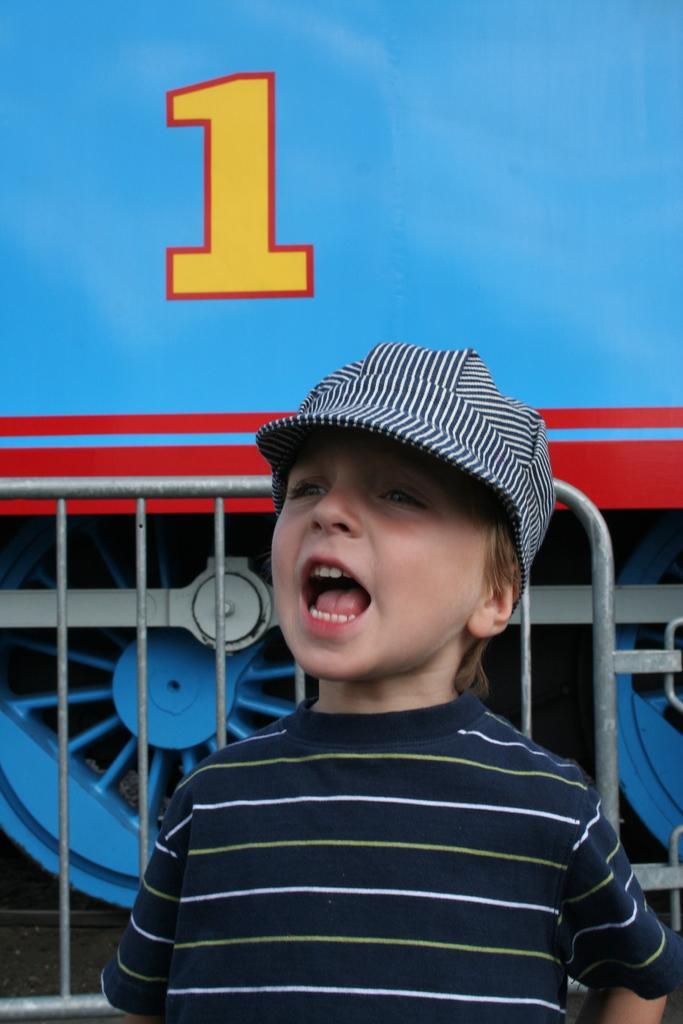How would you summarize this image in a sentence or two? In this picture we can see a child wore a cap, rods and in the background we can see a vehicle. 